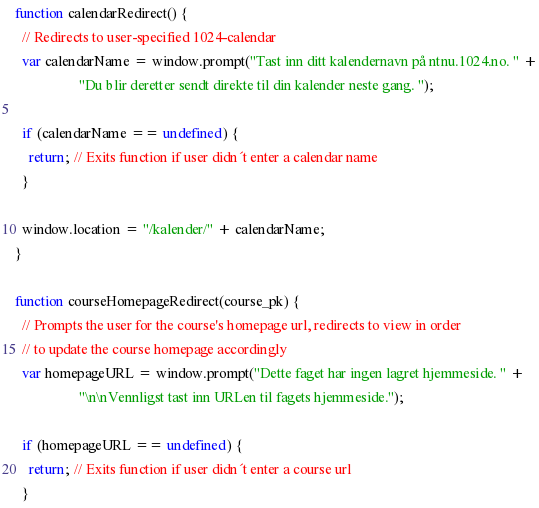Convert code to text. <code><loc_0><loc_0><loc_500><loc_500><_JavaScript_>function calendarRedirect() {
  // Redirects to user-specified 1024-calendar
  var calendarName = window.prompt("Tast inn ditt kalendernavn på ntnu.1024.no. " +
                  "Du blir deretter sendt direkte til din kalender neste gang. ");

  if (calendarName == undefined) {
    return; // Exits function if user didn´t enter a calendar name
  }

  window.location = "/kalender/" + calendarName;
}

function courseHomepageRedirect(course_pk) {
  // Prompts the user for the course's homepage url, redirects to view in order
  // to update the course homepage accordingly
  var homepageURL = window.prompt("Dette faget har ingen lagret hjemmeside. " +
                  "\n\nVennligst tast inn URLen til fagets hjemmeside.");

  if (homepageURL == undefined) {
    return; // Exits function if user didn´t enter a course url
  }
</code> 